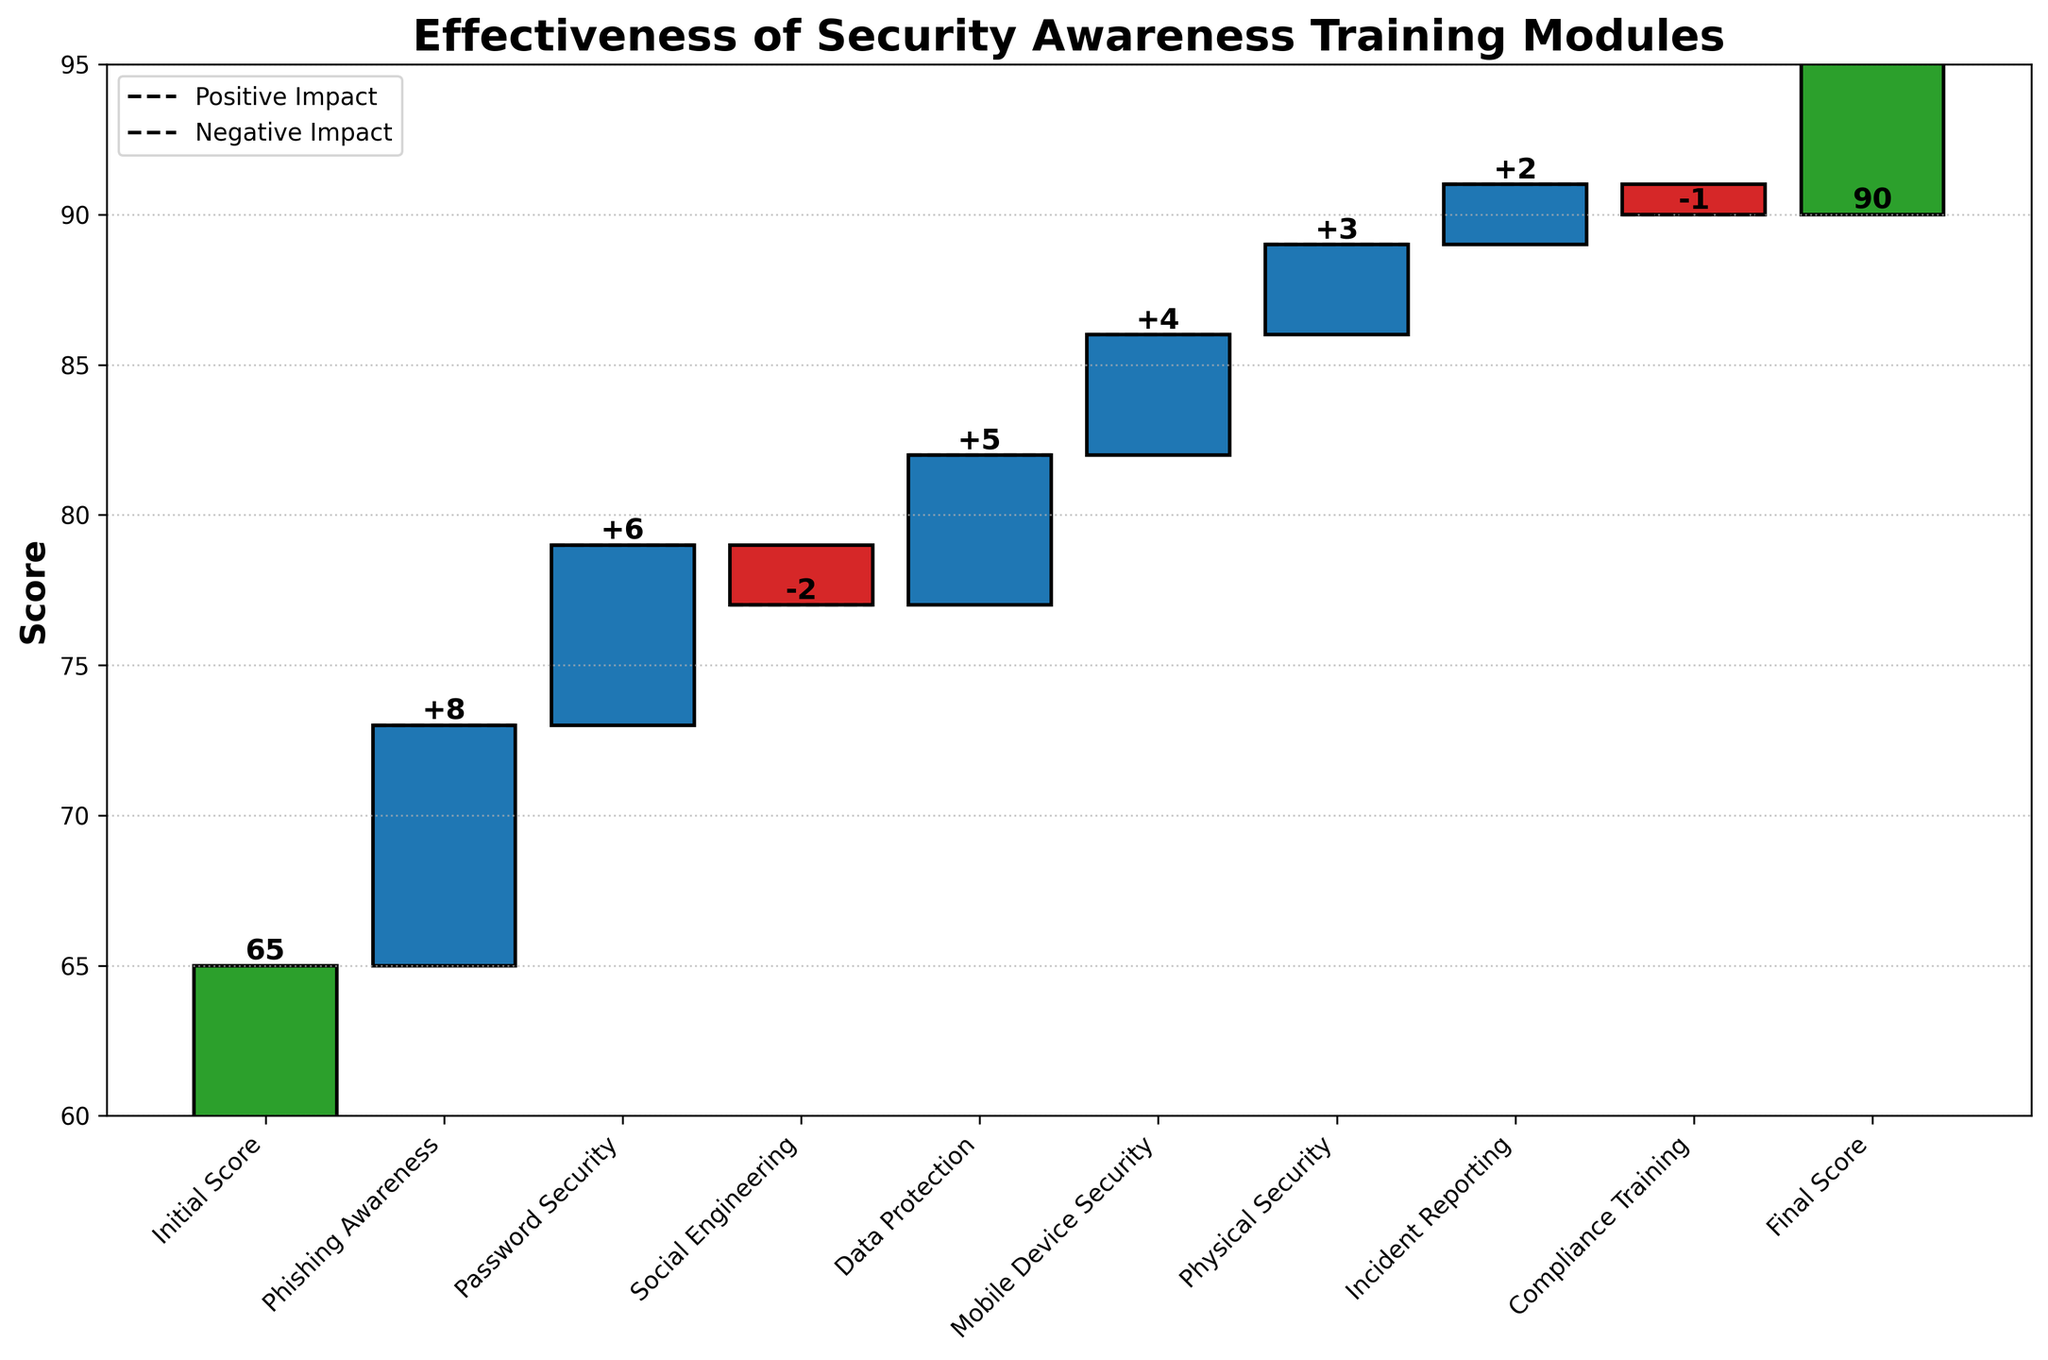What's the title of the chart? The title is shown at the top of the chart.
Answer: Effectiveness of Security Awareness Training Modules What is the initial score? The initial score is the first value on the chart.
Answer: 65 What's the final score? The final score is the last value on the chart.
Answer: 90 Which training module had the highest positive impact on the score? Phishing Awareness has the highest positive impact because it has the largest increase marked by the highest green bar.
Answer: Phishing Awareness Which module caused a decrease in the score? The bars with red color show a negative impact on the score; thus, Social Engineering and Compliance Training decreased the score.
Answer: Social Engineering, Compliance Training How much did Password Security increase the score? The increment due to Password Security is indicated by the height of its green bar (+6).
Answer: 6 What is the combined effect of Phishing Awareness, Password Security, and Data Protection on the score? Adding the individual effects: +8 (Phishing Awareness) + 6 (Password Security) + 5 (Data Protection) = 19.
Answer: 19 Which modules had a positive impact but smaller than Mobile Device Security? All green bars shorter than the Mobile Device Security green bar indicate this. So, social Engineering (+4), and Physical Security (+3).
Answer: Physical Security, Incident Reporting What is the difference in impact between Social Engineering and Mobile Device Security? Social Engineering has a -2 impact, and Mobile Device Security has a +4 impact. The difference is: 4 - (-2) = 4 + 2 = 6.
Answer: 6 By how much did Incident Reporting improve the score? The increment due to Incident Reporting is indicated by the height of its green bar (+2).
Answer: 2 